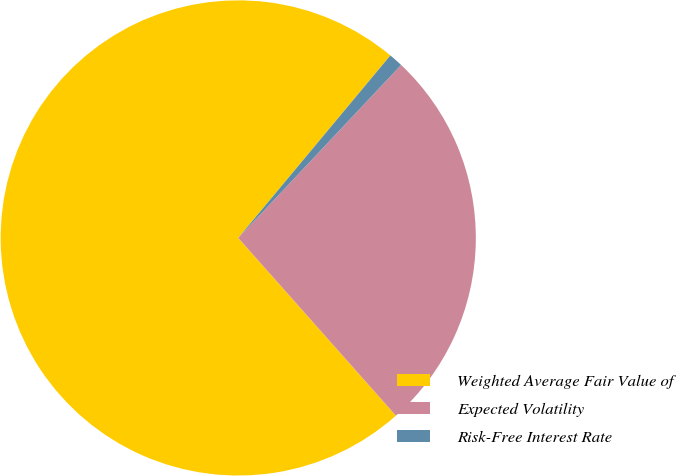<chart> <loc_0><loc_0><loc_500><loc_500><pie_chart><fcel>Weighted Average Fair Value of<fcel>Expected Volatility<fcel>Risk-Free Interest Rate<nl><fcel>72.61%<fcel>26.43%<fcel>0.96%<nl></chart> 